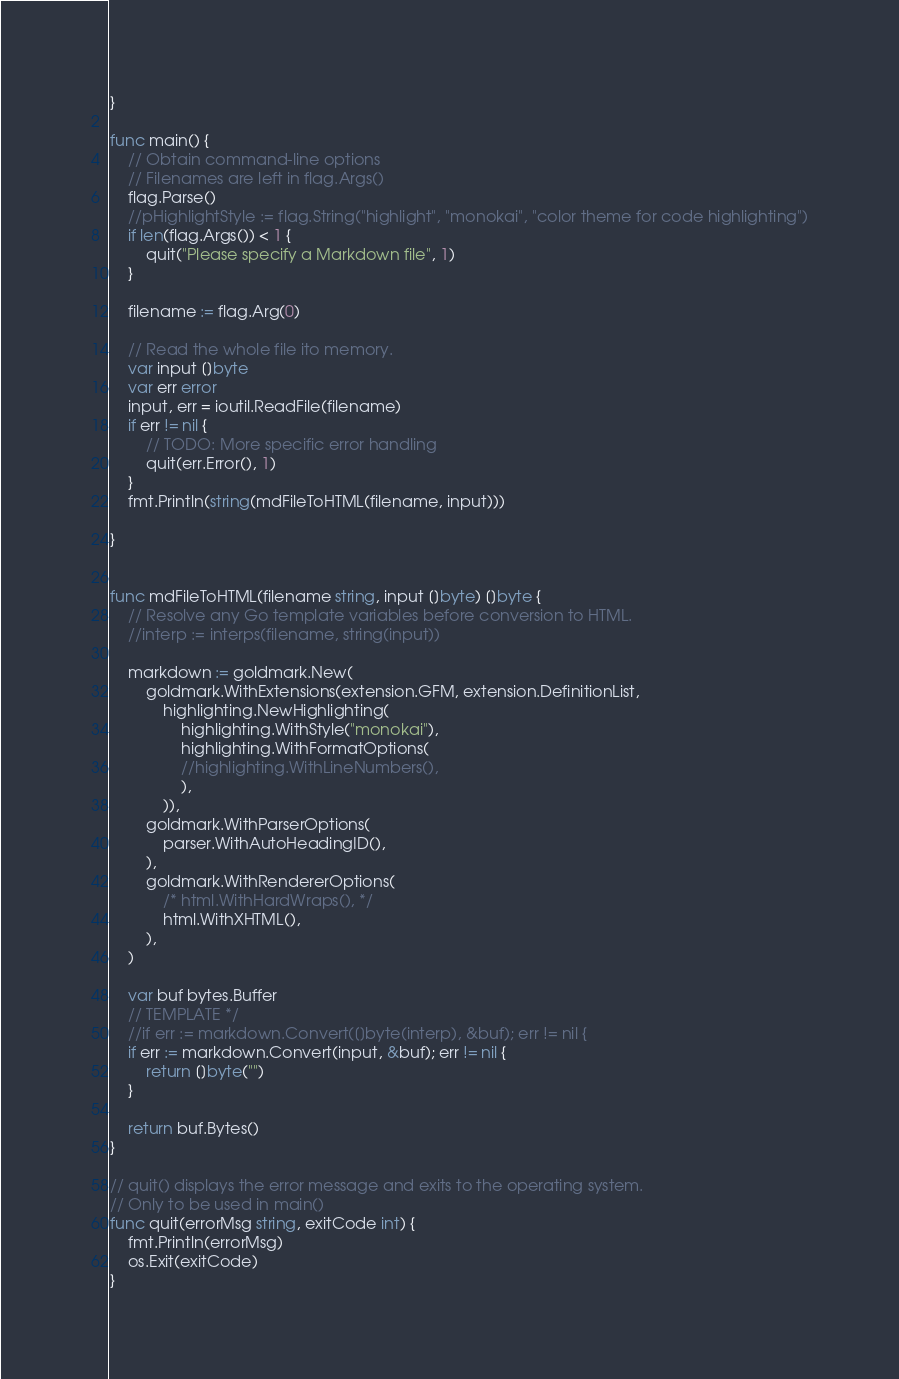Convert code to text. <code><loc_0><loc_0><loc_500><loc_500><_Go_>}

func main() {
	// Obtain command-line options
	// Filenames are left in flag.Args()
	flag.Parse()
	//pHighlightStyle := flag.String("highlight", "monokai", "color theme for code highlighting")
	if len(flag.Args()) < 1 {
		quit("Please specify a Markdown file", 1)
	}

	filename := flag.Arg(0)

	// Read the whole file ito memory.
	var input []byte
	var err error
	input, err = ioutil.ReadFile(filename)
	if err != nil {
		// TODO: More specific error handling
		quit(err.Error(), 1)
	}
	fmt.Println(string(mdFileToHTML(filename, input)))

}


func mdFileToHTML(filename string, input []byte) []byte {
	// Resolve any Go template variables before conversion to HTML.
	//interp := interps(filename, string(input))

	markdown := goldmark.New(
		goldmark.WithExtensions(extension.GFM, extension.DefinitionList,
			highlighting.NewHighlighting(
				highlighting.WithStyle("monokai"),
				highlighting.WithFormatOptions(
				//highlighting.WithLineNumbers(),
				),
			)),
		goldmark.WithParserOptions(
			parser.WithAutoHeadingID(),
		),
		goldmark.WithRendererOptions(
			/* html.WithHardWraps(), */
			html.WithXHTML(),
		),
	)

	var buf bytes.Buffer
	// TEMPLATE */
	//if err := markdown.Convert([]byte(interp), &buf); err != nil {
	if err := markdown.Convert(input, &buf); err != nil {
		return []byte("")
	}

	return buf.Bytes()
}

// quit() displays the error message and exits to the operating system.
// Only to be used in main()
func quit(errorMsg string, exitCode int) {
	fmt.Println(errorMsg)
	os.Exit(exitCode)
}


</code> 